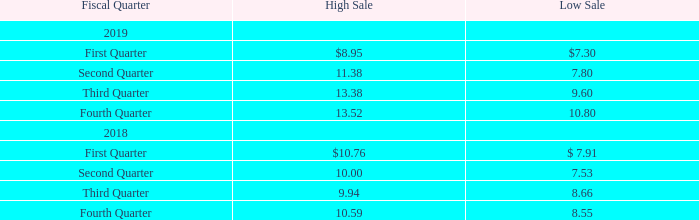MARKET PRICES OF COMMON STOCK
The common stock of the Company is listed on the NASDAQ Global Market under the symbol “FEIM.”
Which global market is the common stock of the Company listed on? Nasdaq. What symbol is the common stock trading under? Feim. What is the high sale and low sale of the first quarter of 2019 respectively? $8.95, $7.30. What is the difference in the high and low sale of the first quarter in 2019? 8.95-7.30
Answer: 1.65. What is the average quarterly low sale price for 2019? (7.30+7.80+9.60+10.80)/4
Answer: 8.88. What is the average quarterly high sale price for 2019? (8.95+11.38+13.38+13.52)/4
Answer: 11.81. 